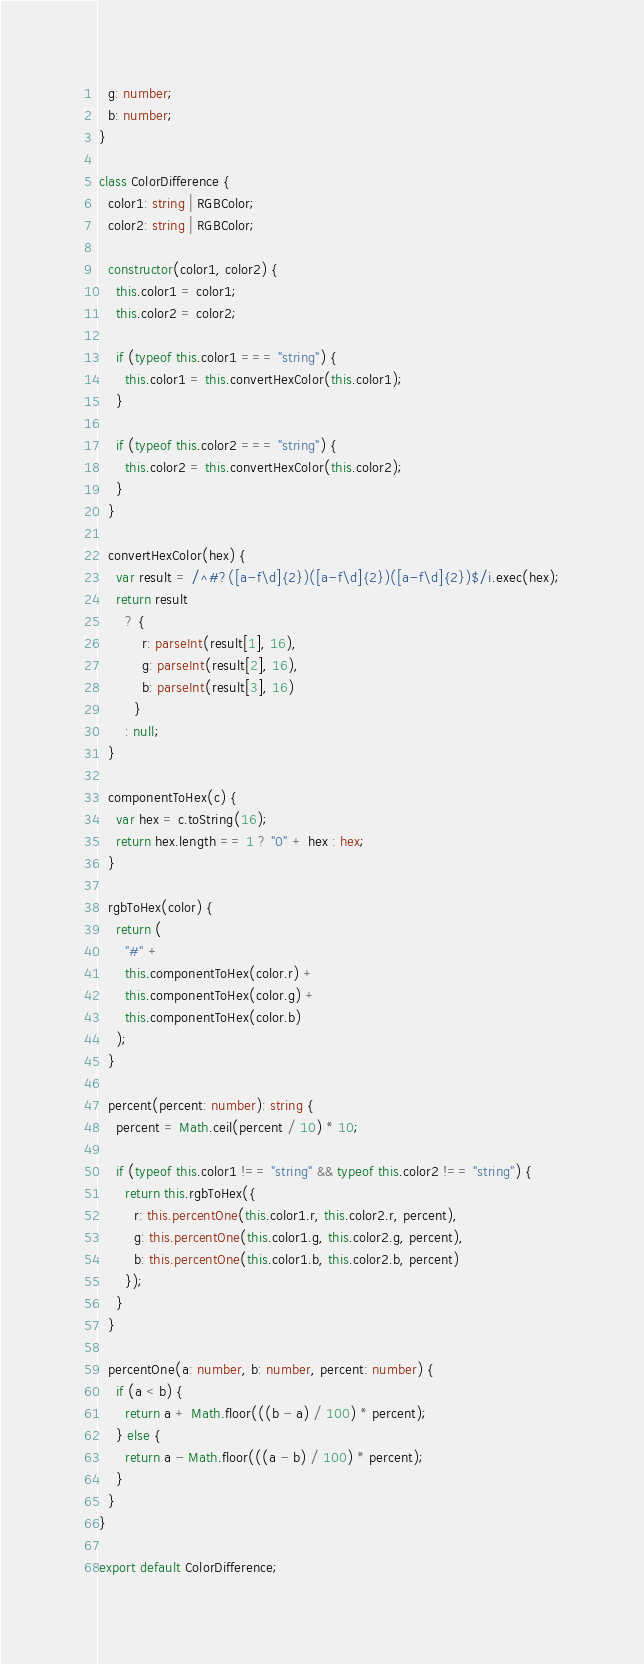<code> <loc_0><loc_0><loc_500><loc_500><_TypeScript_>  g: number;
  b: number;
}

class ColorDifference {
  color1: string | RGBColor;
  color2: string | RGBColor;

  constructor(color1, color2) {
    this.color1 = color1;
    this.color2 = color2;

    if (typeof this.color1 === "string") {
      this.color1 = this.convertHexColor(this.color1);
    }

    if (typeof this.color2 === "string") {
      this.color2 = this.convertHexColor(this.color2);
    }
  }

  convertHexColor(hex) {
    var result = /^#?([a-f\d]{2})([a-f\d]{2})([a-f\d]{2})$/i.exec(hex);
    return result
      ? {
          r: parseInt(result[1], 16),
          g: parseInt(result[2], 16),
          b: parseInt(result[3], 16)
        }
      : null;
  }

  componentToHex(c) {
    var hex = c.toString(16);
    return hex.length == 1 ? "0" + hex : hex;
  }

  rgbToHex(color) {
    return (
      "#" +
      this.componentToHex(color.r) +
      this.componentToHex(color.g) +
      this.componentToHex(color.b)
    );
  }

  percent(percent: number): string {
    percent = Math.ceil(percent / 10) * 10;

    if (typeof this.color1 !== "string" && typeof this.color2 !== "string") {
      return this.rgbToHex({
        r: this.percentOne(this.color1.r, this.color2.r, percent),
        g: this.percentOne(this.color1.g, this.color2.g, percent),
        b: this.percentOne(this.color1.b, this.color2.b, percent)
      });
    }
  }

  percentOne(a: number, b: number, percent: number) {
    if (a < b) {
      return a + Math.floor(((b - a) / 100) * percent);
    } else {
      return a - Math.floor(((a - b) / 100) * percent);
    }
  }
}

export default ColorDifference;
</code> 